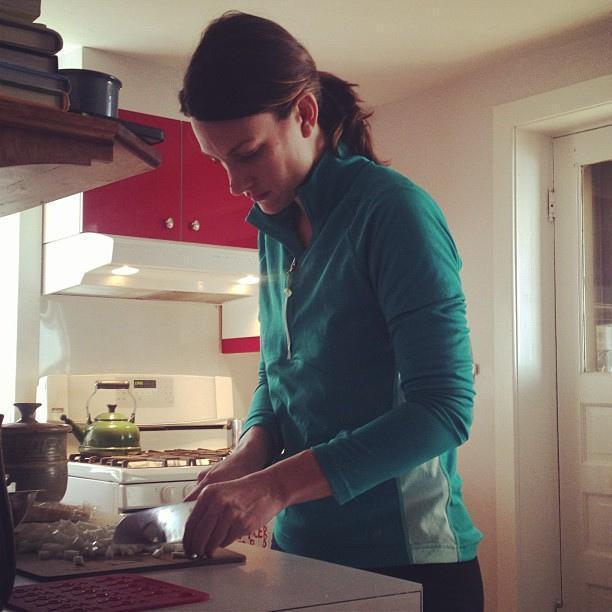How many knives are in the picture?
Give a very brief answer. 1. 